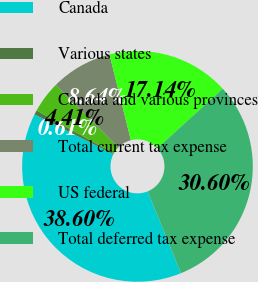Convert chart. <chart><loc_0><loc_0><loc_500><loc_500><pie_chart><fcel>Canada<fcel>Various states<fcel>Canada and various provinces<fcel>Total current tax expense<fcel>US federal<fcel>Total deferred tax expense<nl><fcel>38.6%<fcel>0.61%<fcel>4.41%<fcel>8.64%<fcel>17.14%<fcel>30.6%<nl></chart> 